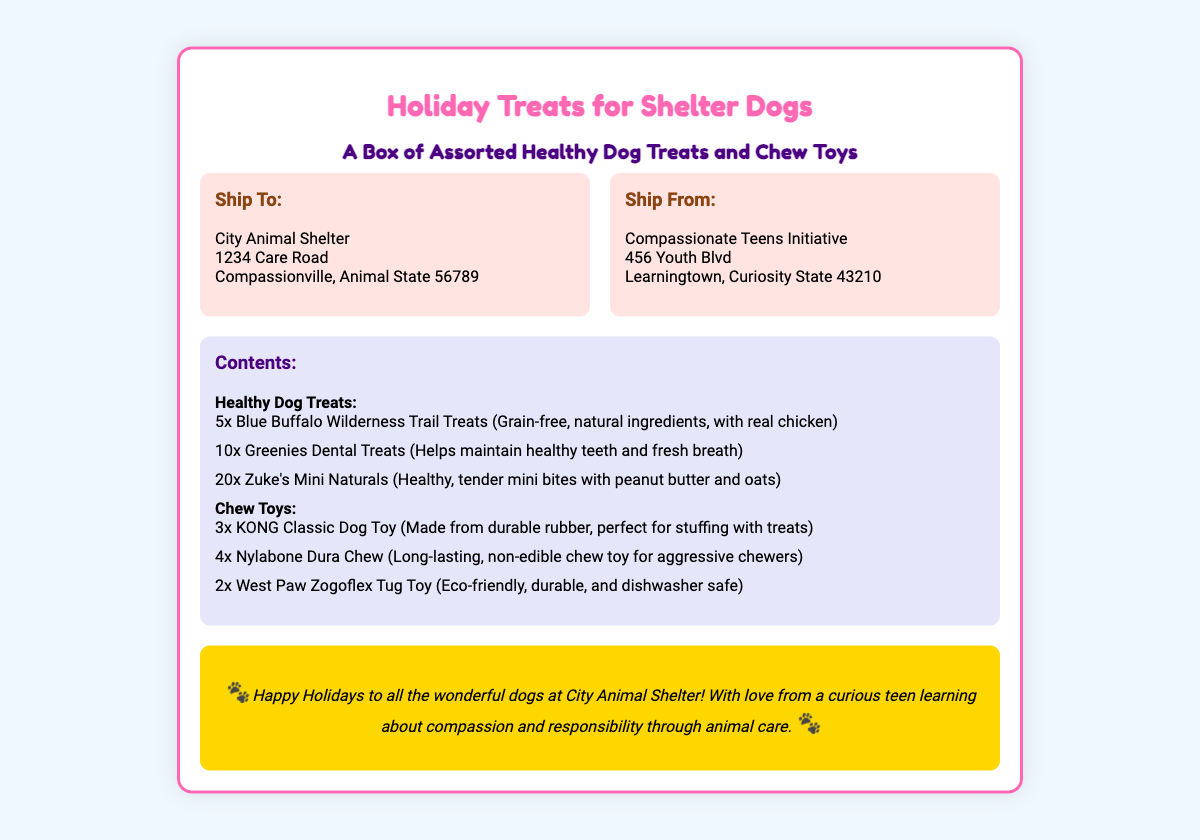what is the title of the document? The title of the document is indicated at the top as "Holiday Treats for Shelter Dogs."
Answer: Holiday Treats for Shelter Dogs who is the recipient of the shipment? The recipient is listed under "Ship To" as City Animal Shelter.
Answer: City Animal Shelter how many Blue Buffalo Wilderness Trail Treats are included? The document specifies that there are 5 Blue Buffalo Wilderness Trail Treats included in the contents.
Answer: 5 what type of dog treats are included for dental health? The document mentions Greenies Dental Treats as the type included for dental health.
Answer: Greenies Dental Treats how many types of chew toys are included? The document lists three types of chew toys under the contents section.
Answer: 3 who is sending the package? The sender is identified under "Ship From" as Compassionate Teens Initiative.
Answer: Compassionate Teens Initiative what is one of the chew toys made from? One of the chew toys, the KONG Classic Dog Toy, is made from durable rubber.
Answer: durable rubber how many Zuke's Mini Naturals are there? There are 20 Zuke's Mini Naturals specified in the contents list.
Answer: 20 what is the purpose of the message at the bottom? The message expresses holiday greetings and a sentiment of compassion from the sender to the shelter dogs.
Answer: Happy Holidays to all the wonderful dogs at City Animal Shelter! 